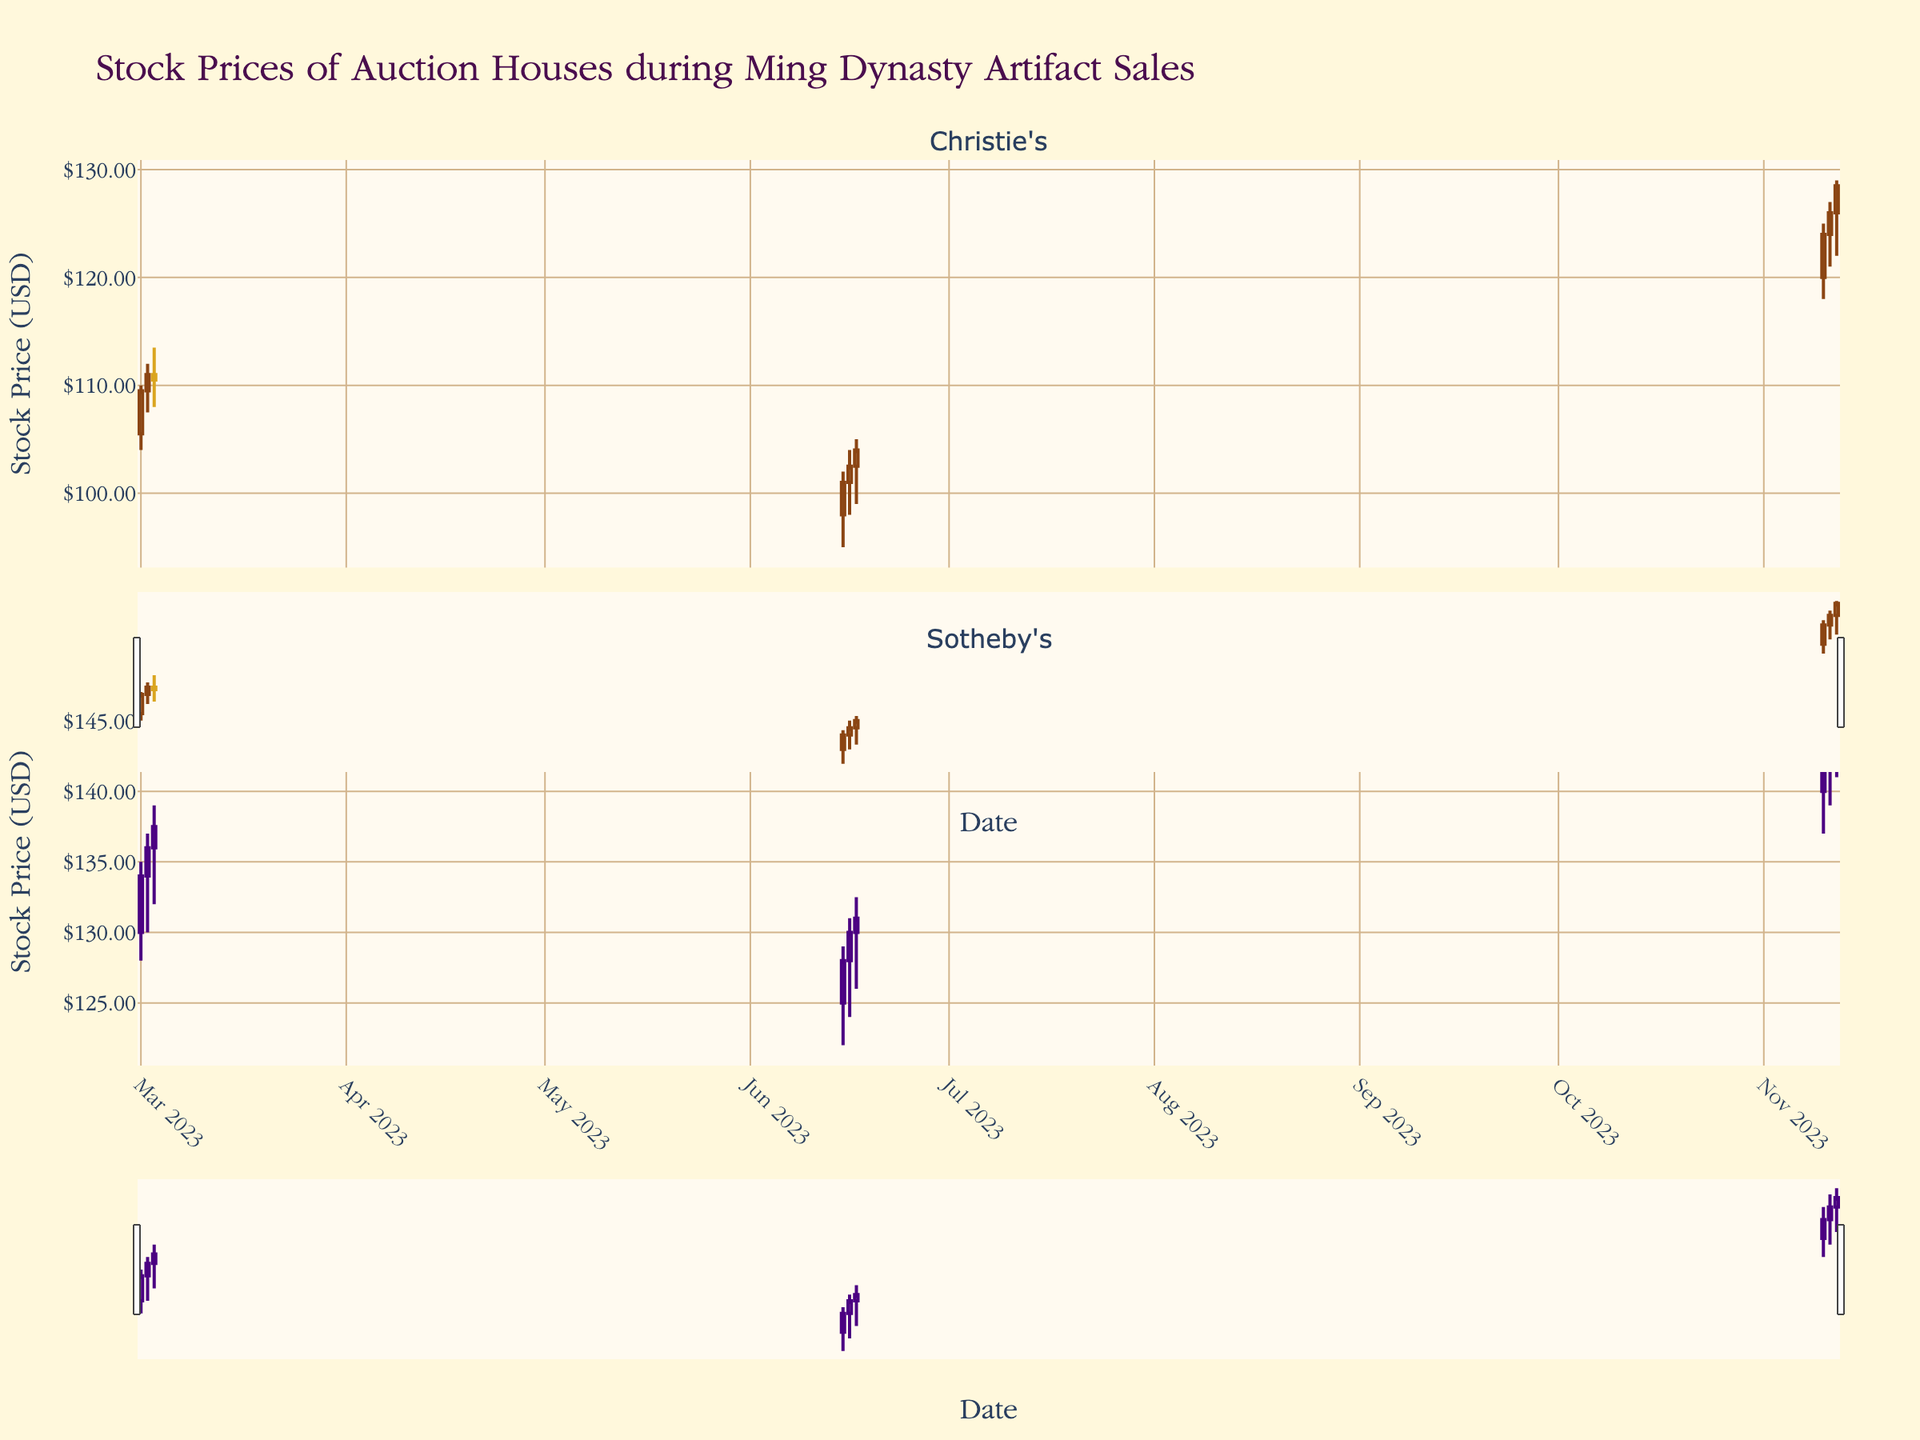What is the title of the plot? The title is located at the top of the plot and provides an overview of the figure's subject matter.
Answer: Stock Prices of Auction Houses during Ming Dynasty Artifact Sales How many subplots are there in the figure? There are two subplots as indicated by the two different company names, each represented in different sections of the figure.
Answer: 2 What is the color used for increasing stock prices for Christie's? The color for increasing stock prices can be determined by observing the color of the candlesticks where the closing price is higher than the opening price.
Answer: Brown On what date did Christie's stock price have the highest volume in March 2023? By examining the volume bars and dates in March 2023 for Christie's subplot, find the date with the highest volume.
Answer: March 2, 2023 Compare the closing prices of Christie's and Sotheby's on June 17, 2023. Which company had a higher closing price? Identify the closing prices on June 17, 2023, for both companies and compare them.
Answer: Sotheby's What is the average closing price for Sotheby's in November 2023? Summing up the closing prices for Sotheby's in November and dividing by the number of days gives the average. (143 + 145 + 146.50) / 3
Answer: 144.83 Which month saw a higher average stock price for Christie's: March or June 2023? Calculate the average stock price for Christie's in March and June, then compare these averages. Average for March: (109.50 + 111.00 + 110.50)/3 = 110.33; Average for June: (101.00 + 102.50 + 104.00)/3 = 102.50.
Answer: March What is the highest closing price for Sotheby's in any of the dates shown in the plot? Identify the highest closing price in the Sotheby's subplot by examining all the dates.
Answer: 146.50 How did Christie's stock price trend from March 1 to March 3, 2023? Observe the candlestick pattern and direction of closing prices from March 1 to March 3, 2023, for Christie's. The closing prices are 109.50, 111.00, and 110.50 respectively.
Answer: Up, then down What can be inferred about the general trend of Sotheby's stock price in November 2023? By observing the closing prices and the general direction of the candlesticks in November 2023, infer whether the trend is upward, downward, or stable.
Answer: Upward 